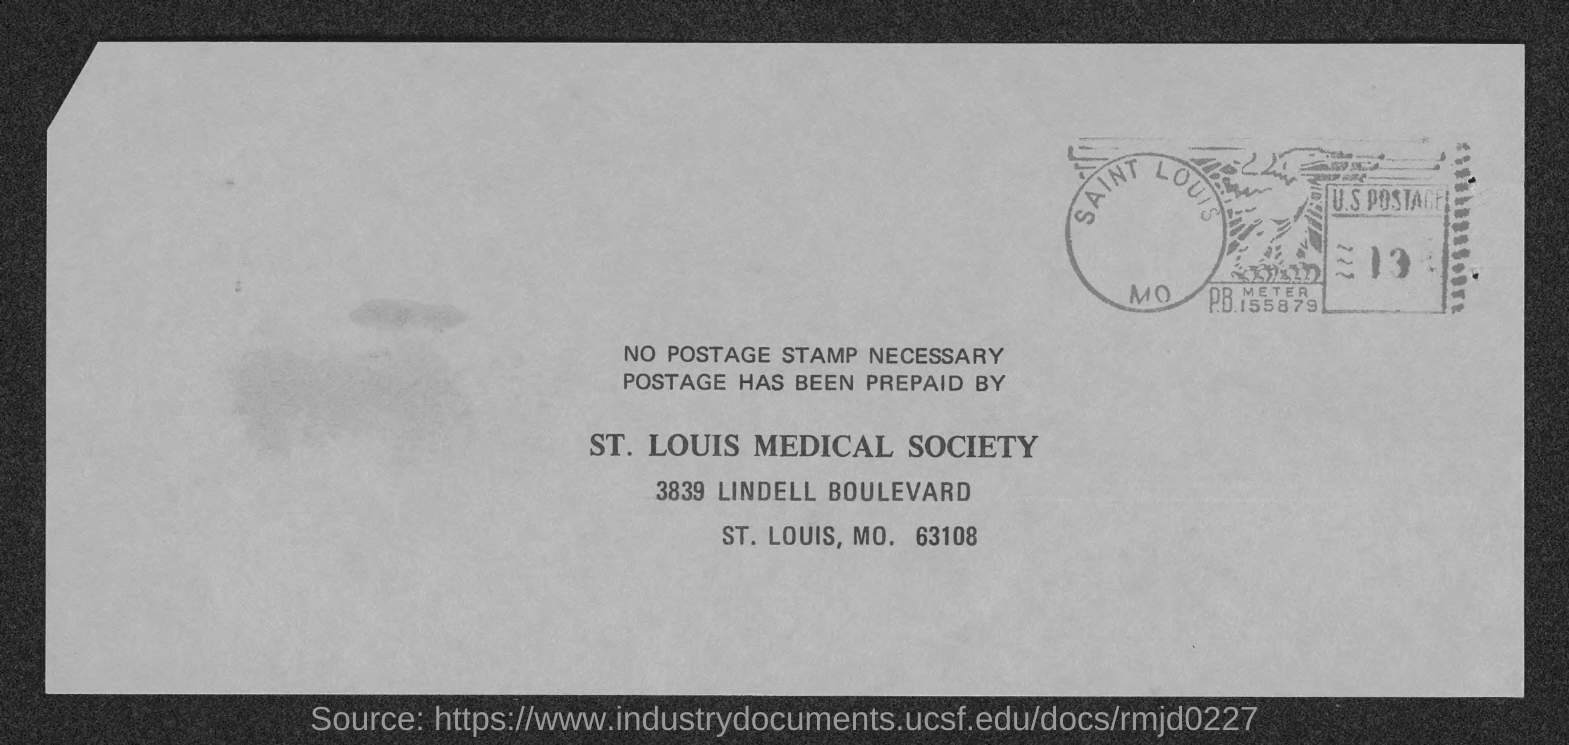Specify some key components in this picture. The St. Louis Medical Society is located at 3839 Lindell Boulevard. 